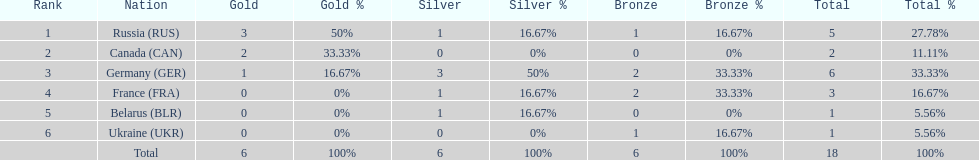What country only received gold medals in the 1994 winter olympics biathlon? Canada (CAN). 